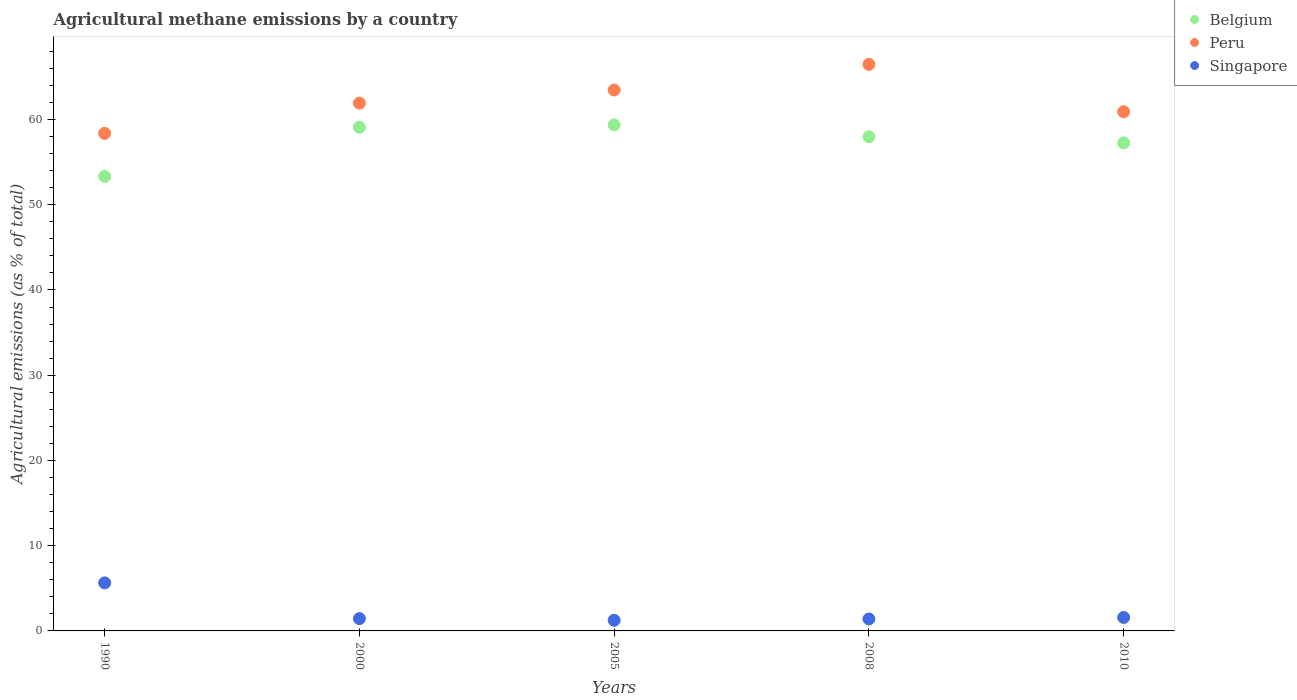How many different coloured dotlines are there?
Provide a short and direct response. 3. Is the number of dotlines equal to the number of legend labels?
Provide a succinct answer. Yes. What is the amount of agricultural methane emitted in Belgium in 2000?
Your answer should be compact. 59.1. Across all years, what is the maximum amount of agricultural methane emitted in Belgium?
Provide a succinct answer. 59.37. Across all years, what is the minimum amount of agricultural methane emitted in Belgium?
Keep it short and to the point. 53.33. In which year was the amount of agricultural methane emitted in Peru maximum?
Give a very brief answer. 2008. In which year was the amount of agricultural methane emitted in Belgium minimum?
Your response must be concise. 1990. What is the total amount of agricultural methane emitted in Peru in the graph?
Keep it short and to the point. 311.15. What is the difference between the amount of agricultural methane emitted in Belgium in 1990 and that in 2000?
Your answer should be compact. -5.77. What is the difference between the amount of agricultural methane emitted in Peru in 2000 and the amount of agricultural methane emitted in Singapore in 2010?
Keep it short and to the point. 60.35. What is the average amount of agricultural methane emitted in Peru per year?
Provide a short and direct response. 62.23. In the year 1990, what is the difference between the amount of agricultural methane emitted in Peru and amount of agricultural methane emitted in Belgium?
Give a very brief answer. 5.05. In how many years, is the amount of agricultural methane emitted in Singapore greater than 56 %?
Offer a very short reply. 0. What is the ratio of the amount of agricultural methane emitted in Belgium in 2005 to that in 2010?
Offer a terse response. 1.04. Is the difference between the amount of agricultural methane emitted in Peru in 2008 and 2010 greater than the difference between the amount of agricultural methane emitted in Belgium in 2008 and 2010?
Keep it short and to the point. Yes. What is the difference between the highest and the second highest amount of agricultural methane emitted in Belgium?
Your response must be concise. 0.28. What is the difference between the highest and the lowest amount of agricultural methane emitted in Belgium?
Provide a short and direct response. 6.04. Is it the case that in every year, the sum of the amount of agricultural methane emitted in Peru and amount of agricultural methane emitted in Belgium  is greater than the amount of agricultural methane emitted in Singapore?
Provide a short and direct response. Yes. Is the amount of agricultural methane emitted in Belgium strictly greater than the amount of agricultural methane emitted in Singapore over the years?
Give a very brief answer. Yes. What is the difference between two consecutive major ticks on the Y-axis?
Provide a short and direct response. 10. Are the values on the major ticks of Y-axis written in scientific E-notation?
Your response must be concise. No. Does the graph contain any zero values?
Your response must be concise. No. Does the graph contain grids?
Offer a terse response. No. Where does the legend appear in the graph?
Make the answer very short. Top right. How many legend labels are there?
Give a very brief answer. 3. What is the title of the graph?
Offer a terse response. Agricultural methane emissions by a country. Does "Kosovo" appear as one of the legend labels in the graph?
Make the answer very short. No. What is the label or title of the Y-axis?
Offer a terse response. Agricultural emissions (as % of total). What is the Agricultural emissions (as % of total) of Belgium in 1990?
Provide a succinct answer. 53.33. What is the Agricultural emissions (as % of total) in Peru in 1990?
Your answer should be very brief. 58.38. What is the Agricultural emissions (as % of total) in Singapore in 1990?
Your response must be concise. 5.63. What is the Agricultural emissions (as % of total) of Belgium in 2000?
Your answer should be compact. 59.1. What is the Agricultural emissions (as % of total) of Peru in 2000?
Offer a very short reply. 61.93. What is the Agricultural emissions (as % of total) in Singapore in 2000?
Keep it short and to the point. 1.44. What is the Agricultural emissions (as % of total) of Belgium in 2005?
Provide a succinct answer. 59.37. What is the Agricultural emissions (as % of total) in Peru in 2005?
Make the answer very short. 63.46. What is the Agricultural emissions (as % of total) of Singapore in 2005?
Offer a very short reply. 1.25. What is the Agricultural emissions (as % of total) in Belgium in 2008?
Keep it short and to the point. 57.98. What is the Agricultural emissions (as % of total) of Peru in 2008?
Your answer should be compact. 66.47. What is the Agricultural emissions (as % of total) in Singapore in 2008?
Provide a short and direct response. 1.4. What is the Agricultural emissions (as % of total) in Belgium in 2010?
Offer a terse response. 57.26. What is the Agricultural emissions (as % of total) of Peru in 2010?
Provide a succinct answer. 60.92. What is the Agricultural emissions (as % of total) in Singapore in 2010?
Your answer should be compact. 1.58. Across all years, what is the maximum Agricultural emissions (as % of total) in Belgium?
Your answer should be very brief. 59.37. Across all years, what is the maximum Agricultural emissions (as % of total) in Peru?
Your answer should be compact. 66.47. Across all years, what is the maximum Agricultural emissions (as % of total) of Singapore?
Ensure brevity in your answer.  5.63. Across all years, what is the minimum Agricultural emissions (as % of total) in Belgium?
Give a very brief answer. 53.33. Across all years, what is the minimum Agricultural emissions (as % of total) in Peru?
Your response must be concise. 58.38. Across all years, what is the minimum Agricultural emissions (as % of total) in Singapore?
Keep it short and to the point. 1.25. What is the total Agricultural emissions (as % of total) in Belgium in the graph?
Keep it short and to the point. 287.04. What is the total Agricultural emissions (as % of total) of Peru in the graph?
Offer a very short reply. 311.15. What is the total Agricultural emissions (as % of total) of Singapore in the graph?
Keep it short and to the point. 11.3. What is the difference between the Agricultural emissions (as % of total) in Belgium in 1990 and that in 2000?
Keep it short and to the point. -5.77. What is the difference between the Agricultural emissions (as % of total) of Peru in 1990 and that in 2000?
Make the answer very short. -3.55. What is the difference between the Agricultural emissions (as % of total) in Singapore in 1990 and that in 2000?
Offer a terse response. 4.19. What is the difference between the Agricultural emissions (as % of total) of Belgium in 1990 and that in 2005?
Provide a succinct answer. -6.04. What is the difference between the Agricultural emissions (as % of total) in Peru in 1990 and that in 2005?
Give a very brief answer. -5.09. What is the difference between the Agricultural emissions (as % of total) of Singapore in 1990 and that in 2005?
Your answer should be very brief. 4.39. What is the difference between the Agricultural emissions (as % of total) of Belgium in 1990 and that in 2008?
Offer a very short reply. -4.65. What is the difference between the Agricultural emissions (as % of total) in Peru in 1990 and that in 2008?
Your response must be concise. -8.1. What is the difference between the Agricultural emissions (as % of total) of Singapore in 1990 and that in 2008?
Your response must be concise. 4.23. What is the difference between the Agricultural emissions (as % of total) in Belgium in 1990 and that in 2010?
Provide a short and direct response. -3.93. What is the difference between the Agricultural emissions (as % of total) of Peru in 1990 and that in 2010?
Keep it short and to the point. -2.54. What is the difference between the Agricultural emissions (as % of total) of Singapore in 1990 and that in 2010?
Offer a terse response. 4.06. What is the difference between the Agricultural emissions (as % of total) of Belgium in 2000 and that in 2005?
Make the answer very short. -0.28. What is the difference between the Agricultural emissions (as % of total) of Peru in 2000 and that in 2005?
Offer a terse response. -1.54. What is the difference between the Agricultural emissions (as % of total) of Singapore in 2000 and that in 2005?
Ensure brevity in your answer.  0.2. What is the difference between the Agricultural emissions (as % of total) in Belgium in 2000 and that in 2008?
Your answer should be very brief. 1.12. What is the difference between the Agricultural emissions (as % of total) in Peru in 2000 and that in 2008?
Make the answer very short. -4.55. What is the difference between the Agricultural emissions (as % of total) in Singapore in 2000 and that in 2008?
Give a very brief answer. 0.04. What is the difference between the Agricultural emissions (as % of total) in Belgium in 2000 and that in 2010?
Your answer should be compact. 1.84. What is the difference between the Agricultural emissions (as % of total) of Peru in 2000 and that in 2010?
Give a very brief answer. 1.01. What is the difference between the Agricultural emissions (as % of total) in Singapore in 2000 and that in 2010?
Your response must be concise. -0.13. What is the difference between the Agricultural emissions (as % of total) in Belgium in 2005 and that in 2008?
Your answer should be very brief. 1.39. What is the difference between the Agricultural emissions (as % of total) in Peru in 2005 and that in 2008?
Give a very brief answer. -3.01. What is the difference between the Agricultural emissions (as % of total) in Singapore in 2005 and that in 2008?
Provide a succinct answer. -0.15. What is the difference between the Agricultural emissions (as % of total) of Belgium in 2005 and that in 2010?
Provide a succinct answer. 2.11. What is the difference between the Agricultural emissions (as % of total) in Peru in 2005 and that in 2010?
Your answer should be compact. 2.55. What is the difference between the Agricultural emissions (as % of total) in Singapore in 2005 and that in 2010?
Provide a short and direct response. -0.33. What is the difference between the Agricultural emissions (as % of total) in Belgium in 2008 and that in 2010?
Offer a very short reply. 0.72. What is the difference between the Agricultural emissions (as % of total) in Peru in 2008 and that in 2010?
Your answer should be compact. 5.56. What is the difference between the Agricultural emissions (as % of total) of Singapore in 2008 and that in 2010?
Keep it short and to the point. -0.18. What is the difference between the Agricultural emissions (as % of total) of Belgium in 1990 and the Agricultural emissions (as % of total) of Peru in 2000?
Your answer should be compact. -8.6. What is the difference between the Agricultural emissions (as % of total) of Belgium in 1990 and the Agricultural emissions (as % of total) of Singapore in 2000?
Keep it short and to the point. 51.89. What is the difference between the Agricultural emissions (as % of total) in Peru in 1990 and the Agricultural emissions (as % of total) in Singapore in 2000?
Offer a terse response. 56.93. What is the difference between the Agricultural emissions (as % of total) of Belgium in 1990 and the Agricultural emissions (as % of total) of Peru in 2005?
Give a very brief answer. -10.13. What is the difference between the Agricultural emissions (as % of total) in Belgium in 1990 and the Agricultural emissions (as % of total) in Singapore in 2005?
Provide a succinct answer. 52.08. What is the difference between the Agricultural emissions (as % of total) of Peru in 1990 and the Agricultural emissions (as % of total) of Singapore in 2005?
Provide a succinct answer. 57.13. What is the difference between the Agricultural emissions (as % of total) of Belgium in 1990 and the Agricultural emissions (as % of total) of Peru in 2008?
Provide a short and direct response. -13.14. What is the difference between the Agricultural emissions (as % of total) of Belgium in 1990 and the Agricultural emissions (as % of total) of Singapore in 2008?
Your response must be concise. 51.93. What is the difference between the Agricultural emissions (as % of total) in Peru in 1990 and the Agricultural emissions (as % of total) in Singapore in 2008?
Make the answer very short. 56.97. What is the difference between the Agricultural emissions (as % of total) in Belgium in 1990 and the Agricultural emissions (as % of total) in Peru in 2010?
Offer a very short reply. -7.59. What is the difference between the Agricultural emissions (as % of total) in Belgium in 1990 and the Agricultural emissions (as % of total) in Singapore in 2010?
Give a very brief answer. 51.75. What is the difference between the Agricultural emissions (as % of total) of Peru in 1990 and the Agricultural emissions (as % of total) of Singapore in 2010?
Ensure brevity in your answer.  56.8. What is the difference between the Agricultural emissions (as % of total) in Belgium in 2000 and the Agricultural emissions (as % of total) in Peru in 2005?
Give a very brief answer. -4.37. What is the difference between the Agricultural emissions (as % of total) of Belgium in 2000 and the Agricultural emissions (as % of total) of Singapore in 2005?
Keep it short and to the point. 57.85. What is the difference between the Agricultural emissions (as % of total) in Peru in 2000 and the Agricultural emissions (as % of total) in Singapore in 2005?
Ensure brevity in your answer.  60.68. What is the difference between the Agricultural emissions (as % of total) in Belgium in 2000 and the Agricultural emissions (as % of total) in Peru in 2008?
Provide a short and direct response. -7.38. What is the difference between the Agricultural emissions (as % of total) of Belgium in 2000 and the Agricultural emissions (as % of total) of Singapore in 2008?
Give a very brief answer. 57.69. What is the difference between the Agricultural emissions (as % of total) of Peru in 2000 and the Agricultural emissions (as % of total) of Singapore in 2008?
Offer a terse response. 60.52. What is the difference between the Agricultural emissions (as % of total) in Belgium in 2000 and the Agricultural emissions (as % of total) in Peru in 2010?
Your response must be concise. -1.82. What is the difference between the Agricultural emissions (as % of total) of Belgium in 2000 and the Agricultural emissions (as % of total) of Singapore in 2010?
Give a very brief answer. 57.52. What is the difference between the Agricultural emissions (as % of total) of Peru in 2000 and the Agricultural emissions (as % of total) of Singapore in 2010?
Provide a succinct answer. 60.35. What is the difference between the Agricultural emissions (as % of total) of Belgium in 2005 and the Agricultural emissions (as % of total) of Peru in 2008?
Offer a terse response. -7.1. What is the difference between the Agricultural emissions (as % of total) in Belgium in 2005 and the Agricultural emissions (as % of total) in Singapore in 2008?
Provide a short and direct response. 57.97. What is the difference between the Agricultural emissions (as % of total) in Peru in 2005 and the Agricultural emissions (as % of total) in Singapore in 2008?
Offer a very short reply. 62.06. What is the difference between the Agricultural emissions (as % of total) of Belgium in 2005 and the Agricultural emissions (as % of total) of Peru in 2010?
Make the answer very short. -1.54. What is the difference between the Agricultural emissions (as % of total) of Belgium in 2005 and the Agricultural emissions (as % of total) of Singapore in 2010?
Your answer should be very brief. 57.8. What is the difference between the Agricultural emissions (as % of total) in Peru in 2005 and the Agricultural emissions (as % of total) in Singapore in 2010?
Offer a very short reply. 61.89. What is the difference between the Agricultural emissions (as % of total) of Belgium in 2008 and the Agricultural emissions (as % of total) of Peru in 2010?
Ensure brevity in your answer.  -2.94. What is the difference between the Agricultural emissions (as % of total) of Belgium in 2008 and the Agricultural emissions (as % of total) of Singapore in 2010?
Your answer should be very brief. 56.4. What is the difference between the Agricultural emissions (as % of total) in Peru in 2008 and the Agricultural emissions (as % of total) in Singapore in 2010?
Provide a short and direct response. 64.89. What is the average Agricultural emissions (as % of total) in Belgium per year?
Your answer should be compact. 57.41. What is the average Agricultural emissions (as % of total) of Peru per year?
Offer a terse response. 62.23. What is the average Agricultural emissions (as % of total) in Singapore per year?
Offer a very short reply. 2.26. In the year 1990, what is the difference between the Agricultural emissions (as % of total) of Belgium and Agricultural emissions (as % of total) of Peru?
Provide a short and direct response. -5.05. In the year 1990, what is the difference between the Agricultural emissions (as % of total) of Belgium and Agricultural emissions (as % of total) of Singapore?
Your answer should be compact. 47.7. In the year 1990, what is the difference between the Agricultural emissions (as % of total) in Peru and Agricultural emissions (as % of total) in Singapore?
Your response must be concise. 52.74. In the year 2000, what is the difference between the Agricultural emissions (as % of total) in Belgium and Agricultural emissions (as % of total) in Peru?
Your answer should be compact. -2.83. In the year 2000, what is the difference between the Agricultural emissions (as % of total) in Belgium and Agricultural emissions (as % of total) in Singapore?
Your answer should be compact. 57.65. In the year 2000, what is the difference between the Agricultural emissions (as % of total) in Peru and Agricultural emissions (as % of total) in Singapore?
Your response must be concise. 60.48. In the year 2005, what is the difference between the Agricultural emissions (as % of total) in Belgium and Agricultural emissions (as % of total) in Peru?
Give a very brief answer. -4.09. In the year 2005, what is the difference between the Agricultural emissions (as % of total) in Belgium and Agricultural emissions (as % of total) in Singapore?
Ensure brevity in your answer.  58.13. In the year 2005, what is the difference between the Agricultural emissions (as % of total) in Peru and Agricultural emissions (as % of total) in Singapore?
Make the answer very short. 62.22. In the year 2008, what is the difference between the Agricultural emissions (as % of total) in Belgium and Agricultural emissions (as % of total) in Peru?
Give a very brief answer. -8.49. In the year 2008, what is the difference between the Agricultural emissions (as % of total) of Belgium and Agricultural emissions (as % of total) of Singapore?
Offer a very short reply. 56.58. In the year 2008, what is the difference between the Agricultural emissions (as % of total) in Peru and Agricultural emissions (as % of total) in Singapore?
Provide a succinct answer. 65.07. In the year 2010, what is the difference between the Agricultural emissions (as % of total) of Belgium and Agricultural emissions (as % of total) of Peru?
Your answer should be very brief. -3.66. In the year 2010, what is the difference between the Agricultural emissions (as % of total) in Belgium and Agricultural emissions (as % of total) in Singapore?
Offer a very short reply. 55.68. In the year 2010, what is the difference between the Agricultural emissions (as % of total) of Peru and Agricultural emissions (as % of total) of Singapore?
Give a very brief answer. 59.34. What is the ratio of the Agricultural emissions (as % of total) in Belgium in 1990 to that in 2000?
Offer a very short reply. 0.9. What is the ratio of the Agricultural emissions (as % of total) of Peru in 1990 to that in 2000?
Provide a short and direct response. 0.94. What is the ratio of the Agricultural emissions (as % of total) in Singapore in 1990 to that in 2000?
Make the answer very short. 3.9. What is the ratio of the Agricultural emissions (as % of total) of Belgium in 1990 to that in 2005?
Offer a terse response. 0.9. What is the ratio of the Agricultural emissions (as % of total) of Peru in 1990 to that in 2005?
Keep it short and to the point. 0.92. What is the ratio of the Agricultural emissions (as % of total) of Singapore in 1990 to that in 2005?
Offer a terse response. 4.52. What is the ratio of the Agricultural emissions (as % of total) of Belgium in 1990 to that in 2008?
Offer a terse response. 0.92. What is the ratio of the Agricultural emissions (as % of total) in Peru in 1990 to that in 2008?
Give a very brief answer. 0.88. What is the ratio of the Agricultural emissions (as % of total) of Singapore in 1990 to that in 2008?
Your response must be concise. 4.02. What is the ratio of the Agricultural emissions (as % of total) in Belgium in 1990 to that in 2010?
Your response must be concise. 0.93. What is the ratio of the Agricultural emissions (as % of total) of Peru in 1990 to that in 2010?
Offer a terse response. 0.96. What is the ratio of the Agricultural emissions (as % of total) of Singapore in 1990 to that in 2010?
Offer a very short reply. 3.57. What is the ratio of the Agricultural emissions (as % of total) of Belgium in 2000 to that in 2005?
Keep it short and to the point. 1. What is the ratio of the Agricultural emissions (as % of total) of Peru in 2000 to that in 2005?
Ensure brevity in your answer.  0.98. What is the ratio of the Agricultural emissions (as % of total) in Singapore in 2000 to that in 2005?
Keep it short and to the point. 1.16. What is the ratio of the Agricultural emissions (as % of total) of Belgium in 2000 to that in 2008?
Keep it short and to the point. 1.02. What is the ratio of the Agricultural emissions (as % of total) in Peru in 2000 to that in 2008?
Ensure brevity in your answer.  0.93. What is the ratio of the Agricultural emissions (as % of total) of Singapore in 2000 to that in 2008?
Make the answer very short. 1.03. What is the ratio of the Agricultural emissions (as % of total) in Belgium in 2000 to that in 2010?
Your answer should be compact. 1.03. What is the ratio of the Agricultural emissions (as % of total) in Peru in 2000 to that in 2010?
Your response must be concise. 1.02. What is the ratio of the Agricultural emissions (as % of total) in Singapore in 2000 to that in 2010?
Your answer should be compact. 0.91. What is the ratio of the Agricultural emissions (as % of total) in Belgium in 2005 to that in 2008?
Offer a very short reply. 1.02. What is the ratio of the Agricultural emissions (as % of total) in Peru in 2005 to that in 2008?
Offer a terse response. 0.95. What is the ratio of the Agricultural emissions (as % of total) of Singapore in 2005 to that in 2008?
Your answer should be very brief. 0.89. What is the ratio of the Agricultural emissions (as % of total) of Belgium in 2005 to that in 2010?
Provide a succinct answer. 1.04. What is the ratio of the Agricultural emissions (as % of total) in Peru in 2005 to that in 2010?
Offer a terse response. 1.04. What is the ratio of the Agricultural emissions (as % of total) in Singapore in 2005 to that in 2010?
Give a very brief answer. 0.79. What is the ratio of the Agricultural emissions (as % of total) of Belgium in 2008 to that in 2010?
Your response must be concise. 1.01. What is the ratio of the Agricultural emissions (as % of total) of Peru in 2008 to that in 2010?
Provide a succinct answer. 1.09. What is the ratio of the Agricultural emissions (as % of total) in Singapore in 2008 to that in 2010?
Provide a succinct answer. 0.89. What is the difference between the highest and the second highest Agricultural emissions (as % of total) in Belgium?
Your response must be concise. 0.28. What is the difference between the highest and the second highest Agricultural emissions (as % of total) of Peru?
Your answer should be very brief. 3.01. What is the difference between the highest and the second highest Agricultural emissions (as % of total) of Singapore?
Keep it short and to the point. 4.06. What is the difference between the highest and the lowest Agricultural emissions (as % of total) in Belgium?
Your answer should be very brief. 6.04. What is the difference between the highest and the lowest Agricultural emissions (as % of total) in Peru?
Provide a short and direct response. 8.1. What is the difference between the highest and the lowest Agricultural emissions (as % of total) of Singapore?
Provide a short and direct response. 4.39. 